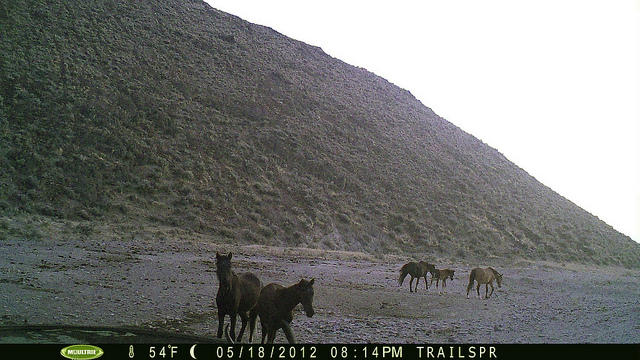Please transcribe the text information in this image. 54 05 18 2012 08 PM 1 4 TRAILSPR &#176;F 